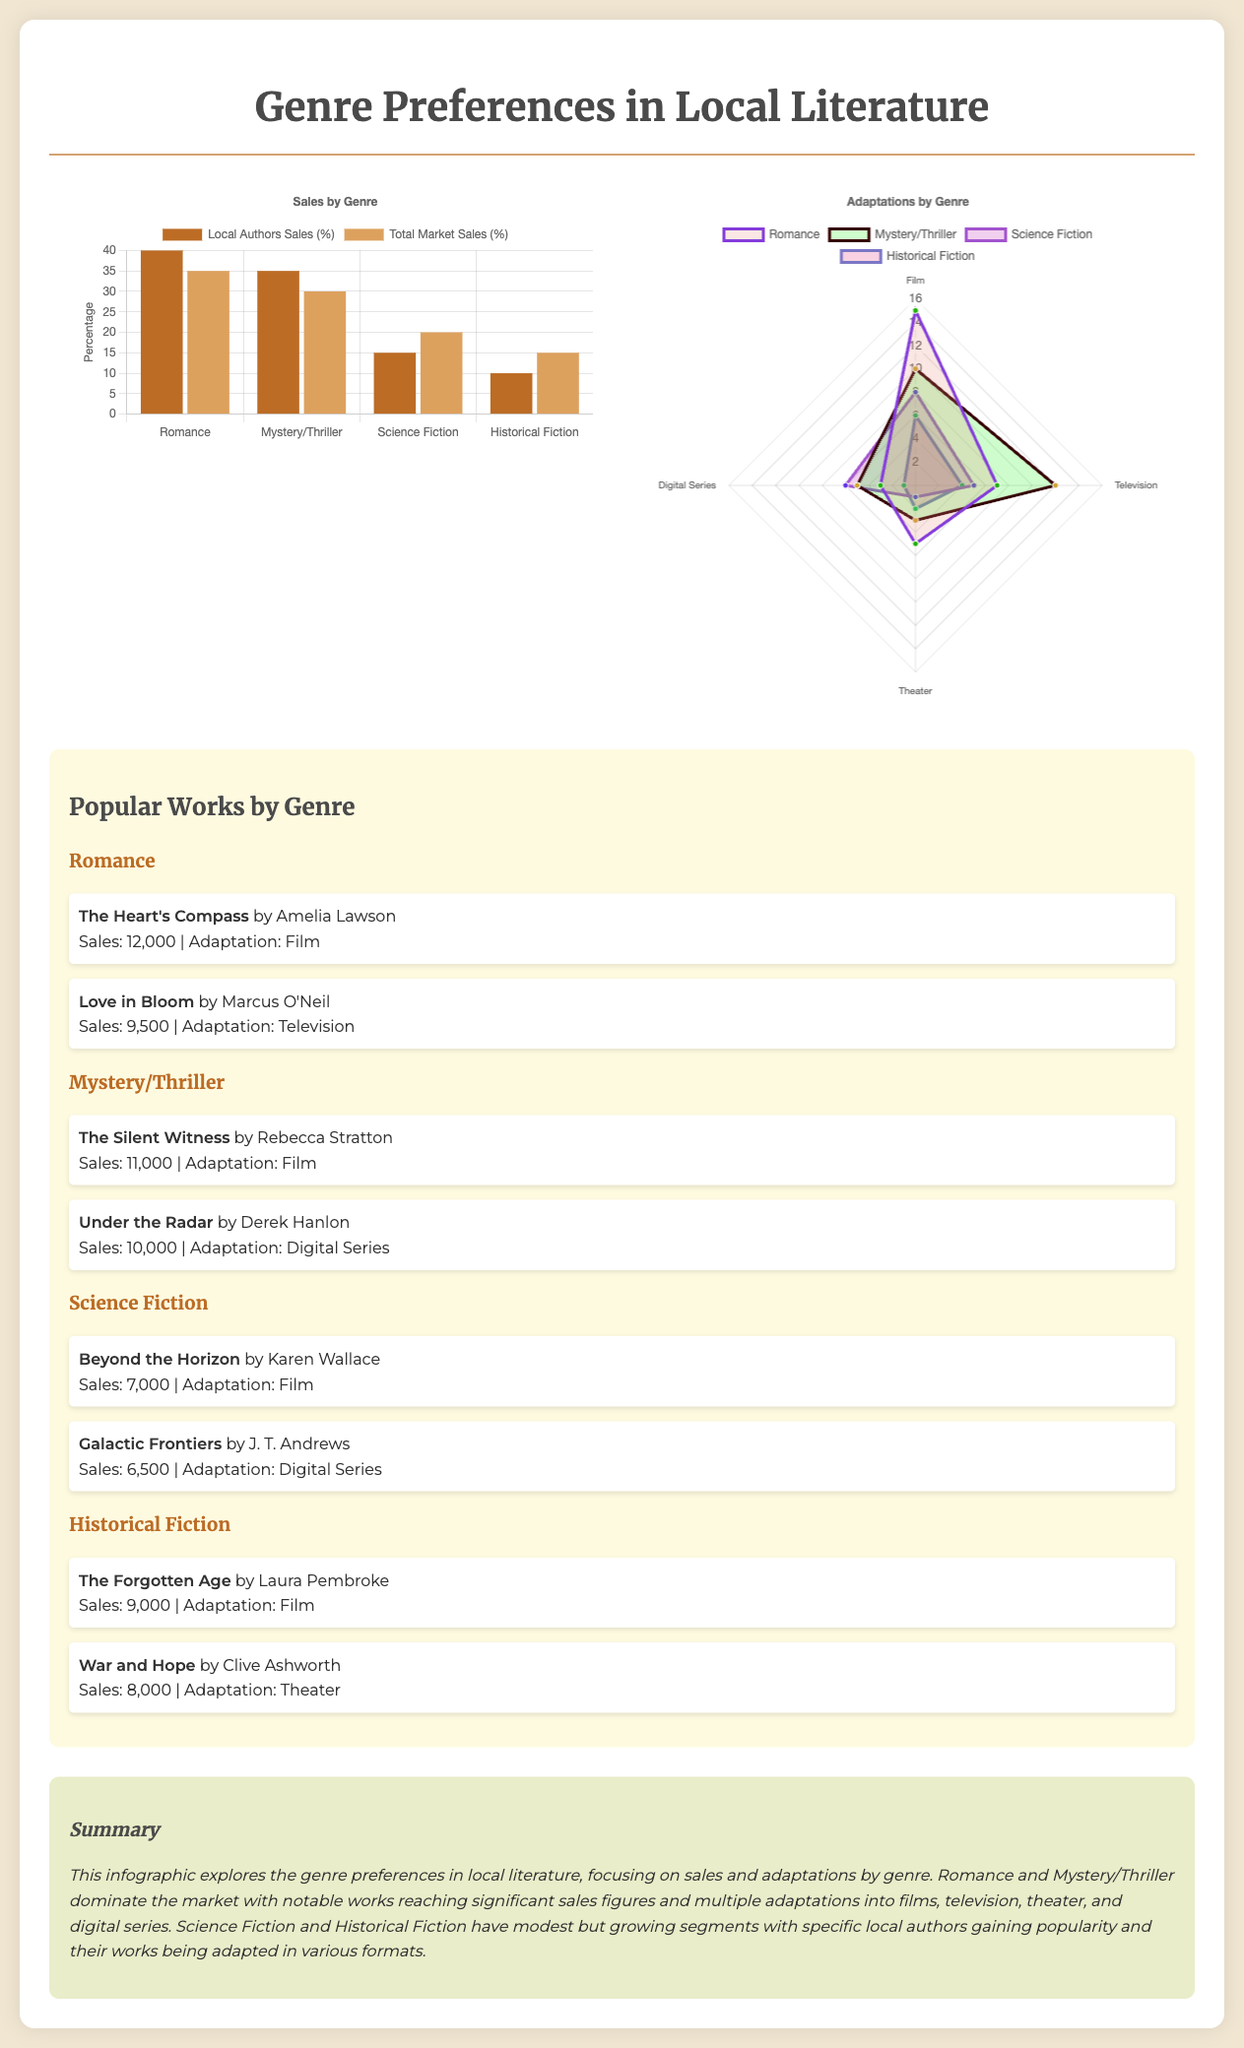What is the top-selling local author genre? The infographic indicates that Romance has the highest sales for local authors.
Answer: Romance How many adaptations does Mystery/Thriller have in film? According to the document, Mystery/Thriller has 10 adaptations in film.
Answer: 10 Which author wrote "The Heart's Compass"? "The Heart's Compass" is written by Amelia Lawson as noted in the popular works section.
Answer: Amelia Lawson What percentage of total market sales does Science Fiction have? The total market sales percentage for Science Fiction is 20%.
Answer: 20% What is the most adapted genre in digital series? The data shows that both Romance and Mystery/Thriller genres have significant adaptations, but Romance has more adaptations in digital series.
Answer: Romance Which genre has the least number of popular works listed? Historical Fiction has the fewest popular works shown in the infographic.
Answer: Historical Fiction How many adaptations are there in theater for Historical Fiction? The infographic states that Historical Fiction has 2 adaptations in theater.
Answer: 2 Which work by J. T. Andrews is noted in the Science Fiction genre? "Galactic Frontiers" is the work by J. T. Andrews mentioned in Science Fiction.
Answer: Galactic Frontiers What is the total sales figure for "Love in Bloom"? The sales for "Love in Bloom" are noted to be 9,500.
Answer: 9,500 